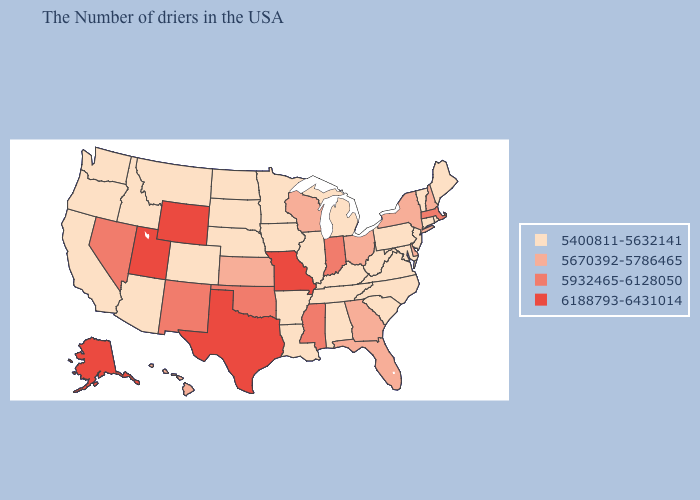Which states have the lowest value in the South?
Be succinct. Maryland, Virginia, North Carolina, South Carolina, West Virginia, Kentucky, Alabama, Tennessee, Louisiana, Arkansas. What is the lowest value in the MidWest?
Concise answer only. 5400811-5632141. What is the value of Georgia?
Keep it brief. 5670392-5786465. Which states have the lowest value in the Northeast?
Give a very brief answer. Maine, Rhode Island, Vermont, Connecticut, New Jersey, Pennsylvania. What is the highest value in the Northeast ?
Write a very short answer. 5932465-6128050. What is the lowest value in the South?
Quick response, please. 5400811-5632141. What is the lowest value in the West?
Concise answer only. 5400811-5632141. What is the value of Arkansas?
Write a very short answer. 5400811-5632141. What is the lowest value in the USA?
Quick response, please. 5400811-5632141. What is the value of North Carolina?
Concise answer only. 5400811-5632141. Does Oregon have a higher value than Texas?
Give a very brief answer. No. What is the highest value in the USA?
Concise answer only. 6188793-6431014. What is the lowest value in the USA?
Keep it brief. 5400811-5632141. Which states hav the highest value in the MidWest?
Keep it brief. Missouri. Name the states that have a value in the range 5932465-6128050?
Concise answer only. Massachusetts, Indiana, Mississippi, Oklahoma, New Mexico, Nevada. 